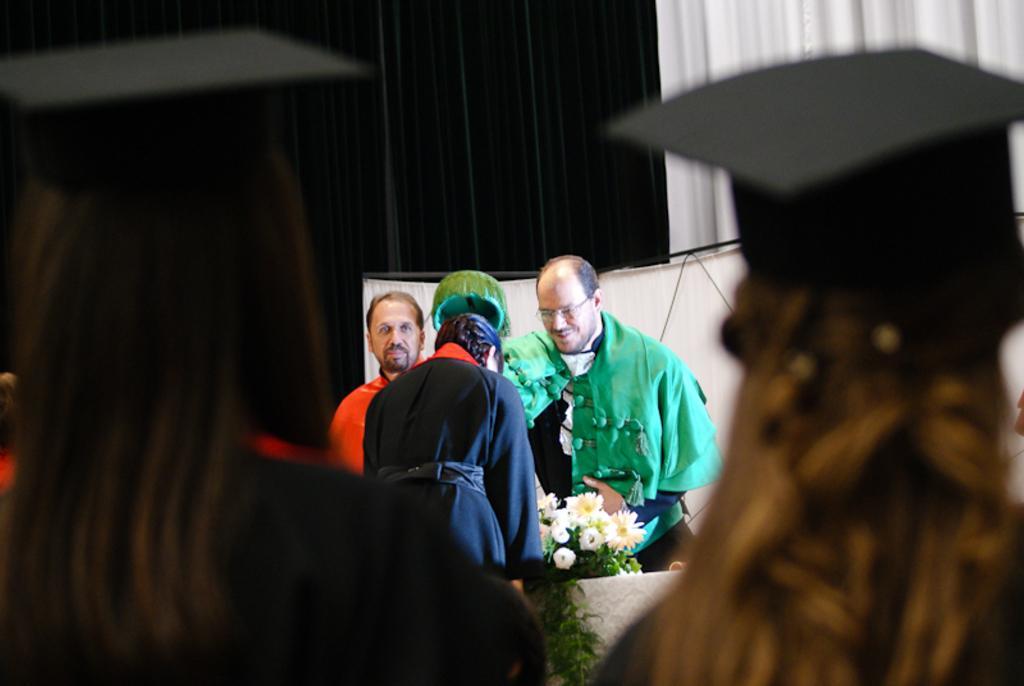Could you give a brief overview of what you see in this image? In the foreground, I can see a group of people and bouquets on the floor. In the background, I can see curtains. This image is taken, maybe in a hall. 